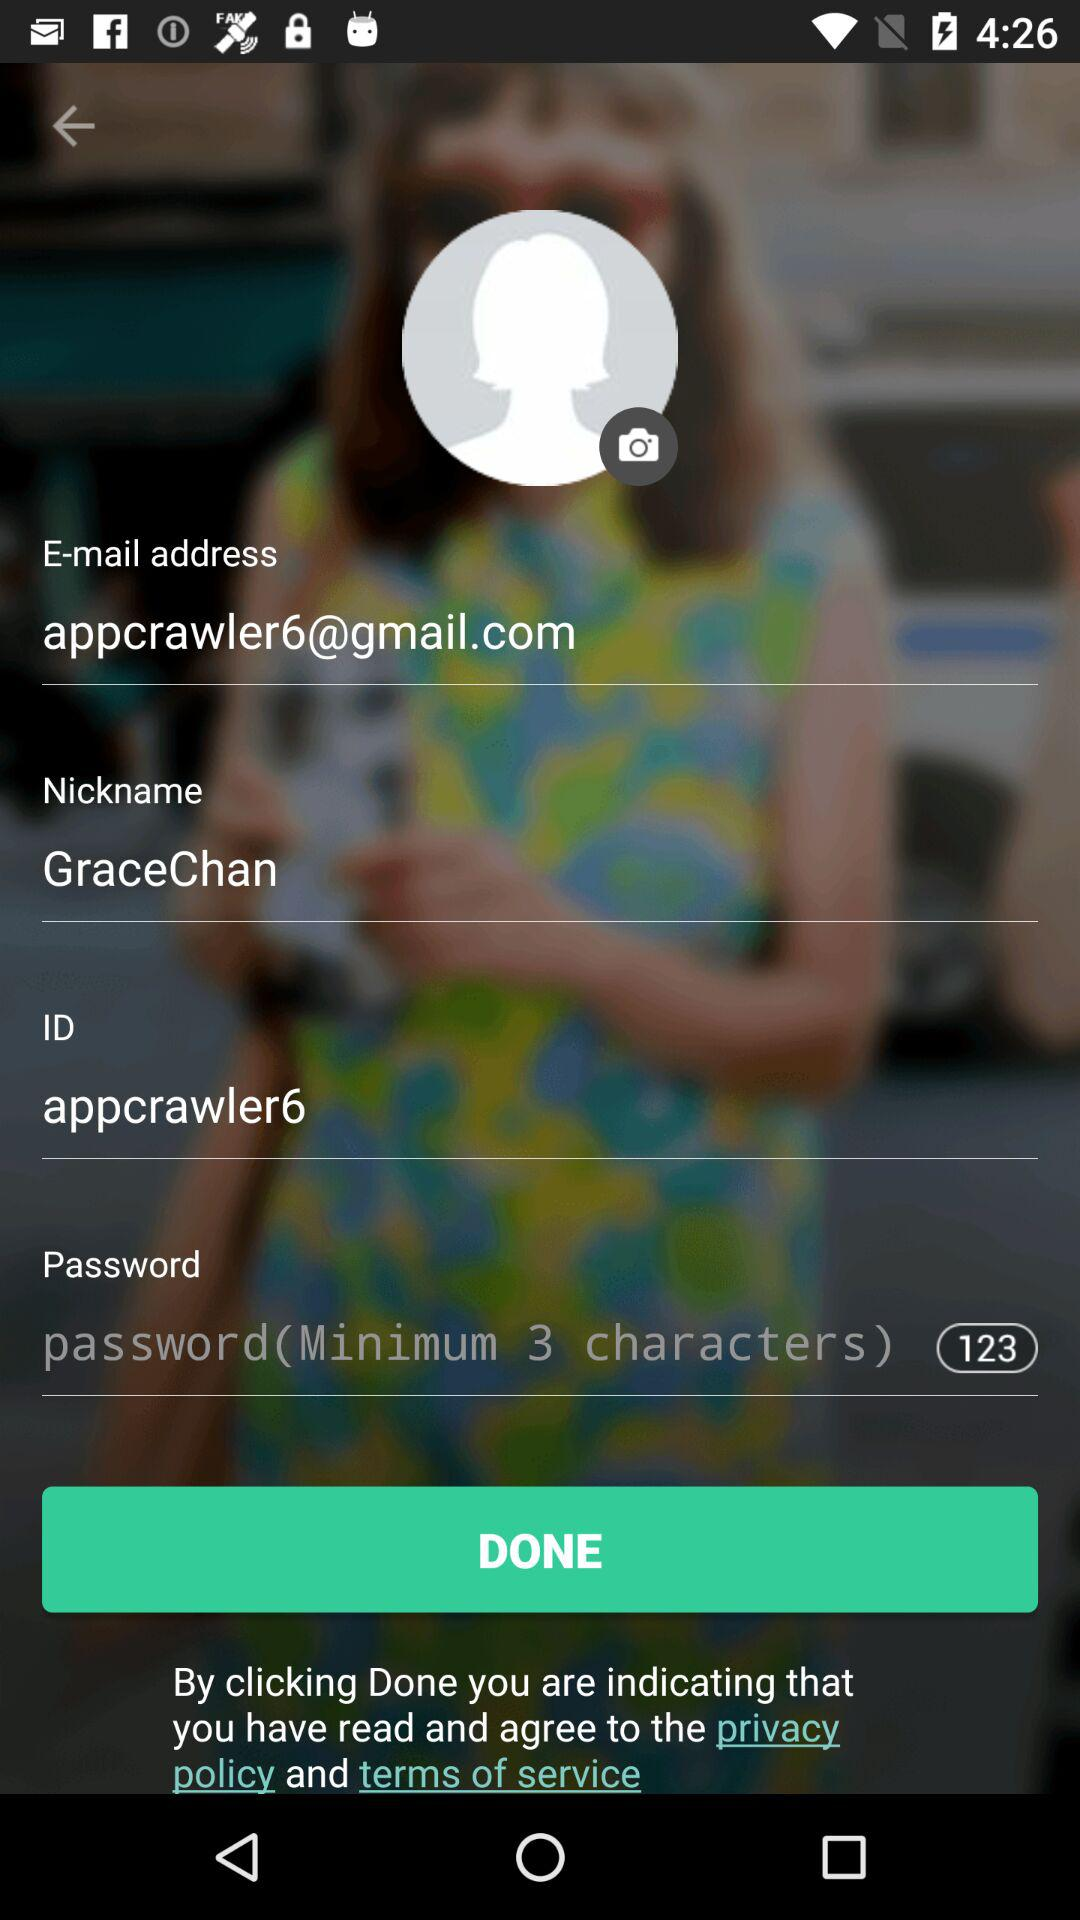What's the identity? The identity is "appcrawler6". 